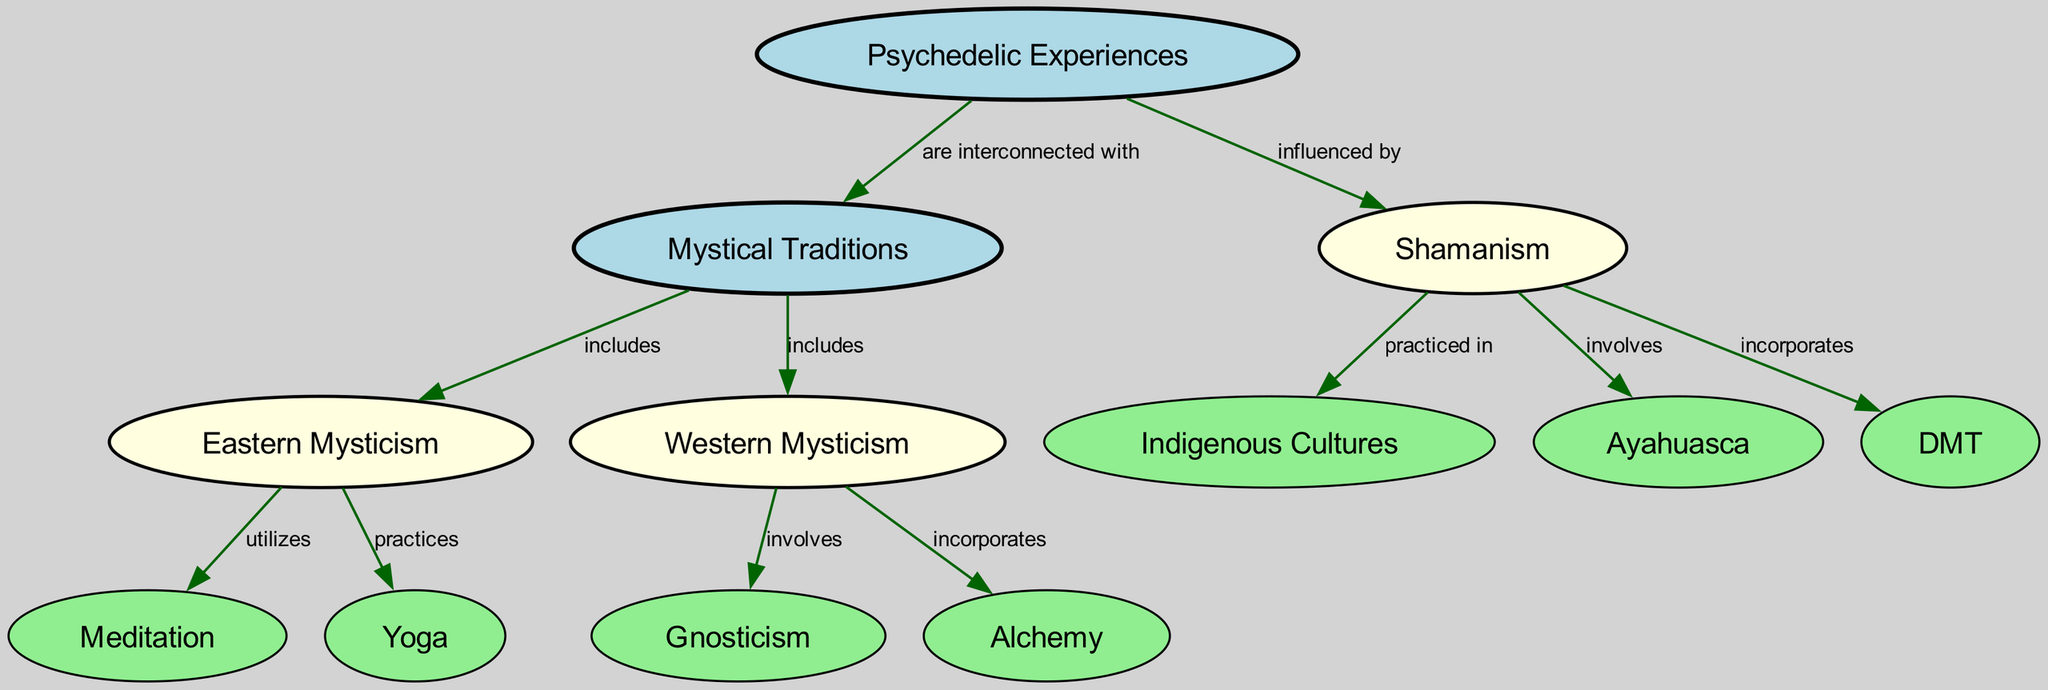What nodes are present in the diagram? The diagram includes several nodes such as 'Psychedelic Experiences', 'Mystical Traditions', 'Shamanism', 'Eastern Mysticism', 'Western Mysticism', 'Indigenous Cultures', 'Ayahuasca', 'DMT', 'Meditation', 'Yoga', 'Gnosticism', and 'Alchemy'. All of these entities represent different aspects of the relationships between psychedelic experiences and mystical traditions.
Answer: Psychedelic Experiences, Mystical Traditions, Shamanism, Eastern Mysticism, Western Mysticism, Indigenous Cultures, Ayahuasca, DMT, Meditation, Yoga, Gnosticism, Alchemy How many edges connect the nodes in the diagram? By counting all the edges that connect the various nodes, we can determine the total. In the provided diagram data, there are 12 edges indicating relationships between the different nodes.
Answer: 12 What is one practice utilized in Eastern Mysticism? The diagram indicates that 'Meditation' is a practice utilized within 'Eastern Mysticism'. This relationship is clearly depicted with a connecting edge.
Answer: Meditation Which tradition incorporates Alchemy? The connection from 'Western Mysticism' to 'Alchemy' in the diagram specifies that it incorporates Alchemy. By following the edges, we can ascertain which tradition is involved.
Answer: Western Mysticism How does Shamanism relate to Indigenous Cultures? The diagram shows that 'Shamanism' is practiced in 'Indigenous Cultures', illustrated by a directed edge connecting these two nodes. This relationship indicates that Shamanism has cultural roots in Indigenous communities.
Answer: practiced in What psychedelic substance is involved in Shamanism? The diagram highlights two substances related to 'Shamanism': 'Ayahuasca' and 'DMT'. Both of these substances are noted for their significance in shamanic practices, so either would be an acceptable answer.
Answer: Ayahuasca or DMT Which mystical tradition involves Gnosticism? According to the diagram, 'Gnosticism' is involved in 'Western Mysticism'. This connection illustrates the relationship between the two concepts, revealing how one tradition contains elements of another.
Answer: Western Mysticism What are two practices typically associated with Eastern Mysticism? From the edges connecting 'Eastern Mysticism' to 'Meditation' and 'Yoga', we can identify two practices that are commonly associated with this mystical tradition. Both practices serve as pathways to accessing the deeper aspects of consciousness.
Answer: Meditation, Yoga How are psychedelic experiences and mystical traditions related? The key edge connecting 'Psychedelic Experiences' to 'Mystical Traditions' signifies that they are interconnected with each other. This connection is foundational to the concept illustrated in the diagram.
Answer: interconnected with 